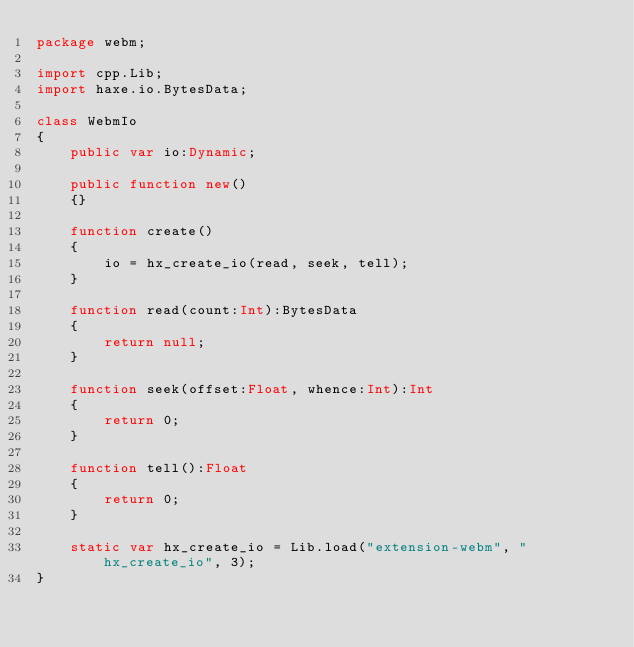Convert code to text. <code><loc_0><loc_0><loc_500><loc_500><_Haxe_>package webm;

import cpp.Lib;
import haxe.io.BytesData;

class WebmIo 
{
	public var io:Dynamic;
	
	public function new() 
	{}
	
	function create()
	{
		io = hx_create_io(read, seek, tell);
	}
	
	function read(count:Int):BytesData 
	{
		return null;
	}
	
	function seek(offset:Float, whence:Int):Int 
	{
		return 0;
	}
	
	function tell():Float 
	{
		return 0;
	}
	
	static var hx_create_io = Lib.load("extension-webm", "hx_create_io", 3);
}</code> 